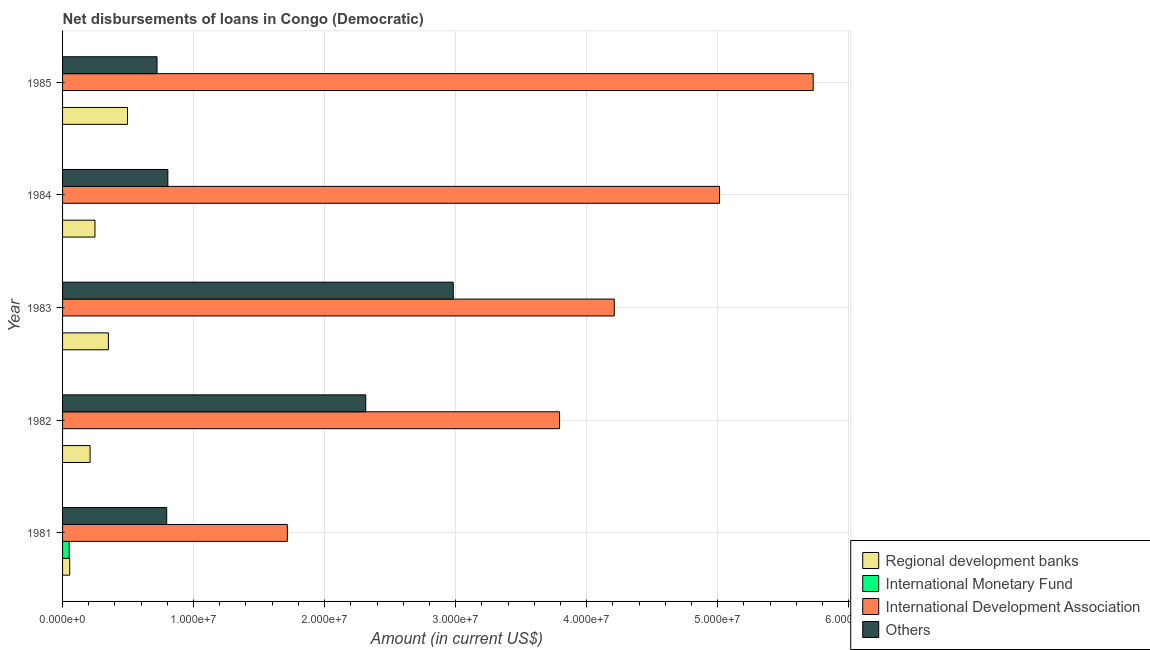How many different coloured bars are there?
Give a very brief answer. 4. Are the number of bars per tick equal to the number of legend labels?
Offer a very short reply. No. How many bars are there on the 4th tick from the top?
Your response must be concise. 3. How many bars are there on the 5th tick from the bottom?
Offer a very short reply. 3. In how many cases, is the number of bars for a given year not equal to the number of legend labels?
Ensure brevity in your answer.  4. What is the amount of loan disimbursed by regional development banks in 1984?
Give a very brief answer. 2.47e+06. Across all years, what is the maximum amount of loan disimbursed by other organisations?
Keep it short and to the point. 2.98e+07. Across all years, what is the minimum amount of loan disimbursed by international development association?
Give a very brief answer. 1.72e+07. What is the total amount of loan disimbursed by international development association in the graph?
Provide a short and direct response. 2.05e+08. What is the difference between the amount of loan disimbursed by international development association in 1981 and that in 1985?
Keep it short and to the point. -4.01e+07. What is the difference between the amount of loan disimbursed by regional development banks in 1981 and the amount of loan disimbursed by international development association in 1982?
Your answer should be very brief. -3.74e+07. What is the average amount of loan disimbursed by international monetary fund per year?
Your response must be concise. 1.01e+05. In the year 1985, what is the difference between the amount of loan disimbursed by international development association and amount of loan disimbursed by regional development banks?
Your response must be concise. 5.23e+07. What is the ratio of the amount of loan disimbursed by regional development banks in 1981 to that in 1985?
Offer a very short reply. 0.11. Is the amount of loan disimbursed by regional development banks in 1984 less than that in 1985?
Ensure brevity in your answer.  Yes. What is the difference between the highest and the second highest amount of loan disimbursed by regional development banks?
Your response must be concise. 1.46e+06. What is the difference between the highest and the lowest amount of loan disimbursed by other organisations?
Your answer should be compact. 2.26e+07. Is the sum of the amount of loan disimbursed by other organisations in 1982 and 1983 greater than the maximum amount of loan disimbursed by international development association across all years?
Your response must be concise. No. Is it the case that in every year, the sum of the amount of loan disimbursed by regional development banks and amount of loan disimbursed by international monetary fund is greater than the amount of loan disimbursed by international development association?
Give a very brief answer. No. How many bars are there?
Your answer should be compact. 16. Are all the bars in the graph horizontal?
Provide a short and direct response. Yes. How many years are there in the graph?
Offer a very short reply. 5. Does the graph contain grids?
Give a very brief answer. Yes. Where does the legend appear in the graph?
Offer a very short reply. Bottom right. How many legend labels are there?
Your answer should be very brief. 4. What is the title of the graph?
Offer a terse response. Net disbursements of loans in Congo (Democratic). Does "Primary education" appear as one of the legend labels in the graph?
Make the answer very short. No. What is the label or title of the Y-axis?
Your response must be concise. Year. What is the Amount (in current US$) of Regional development banks in 1981?
Offer a terse response. 5.46e+05. What is the Amount (in current US$) in International Monetary Fund in 1981?
Give a very brief answer. 5.04e+05. What is the Amount (in current US$) of International Development Association in 1981?
Give a very brief answer. 1.72e+07. What is the Amount (in current US$) of Others in 1981?
Make the answer very short. 7.95e+06. What is the Amount (in current US$) in Regional development banks in 1982?
Make the answer very short. 2.10e+06. What is the Amount (in current US$) of International Monetary Fund in 1982?
Keep it short and to the point. 0. What is the Amount (in current US$) in International Development Association in 1982?
Make the answer very short. 3.79e+07. What is the Amount (in current US$) in Others in 1982?
Offer a very short reply. 2.31e+07. What is the Amount (in current US$) of Regional development banks in 1983?
Keep it short and to the point. 3.50e+06. What is the Amount (in current US$) of International Monetary Fund in 1983?
Offer a very short reply. 0. What is the Amount (in current US$) of International Development Association in 1983?
Ensure brevity in your answer.  4.21e+07. What is the Amount (in current US$) in Others in 1983?
Give a very brief answer. 2.98e+07. What is the Amount (in current US$) in Regional development banks in 1984?
Your response must be concise. 2.47e+06. What is the Amount (in current US$) in International Monetary Fund in 1984?
Provide a short and direct response. 0. What is the Amount (in current US$) in International Development Association in 1984?
Provide a short and direct response. 5.01e+07. What is the Amount (in current US$) in Others in 1984?
Make the answer very short. 8.04e+06. What is the Amount (in current US$) of Regional development banks in 1985?
Make the answer very short. 4.96e+06. What is the Amount (in current US$) in International Monetary Fund in 1985?
Offer a terse response. 0. What is the Amount (in current US$) in International Development Association in 1985?
Provide a short and direct response. 5.73e+07. What is the Amount (in current US$) of Others in 1985?
Offer a terse response. 7.21e+06. Across all years, what is the maximum Amount (in current US$) in Regional development banks?
Provide a succinct answer. 4.96e+06. Across all years, what is the maximum Amount (in current US$) in International Monetary Fund?
Provide a succinct answer. 5.04e+05. Across all years, what is the maximum Amount (in current US$) of International Development Association?
Keep it short and to the point. 5.73e+07. Across all years, what is the maximum Amount (in current US$) of Others?
Keep it short and to the point. 2.98e+07. Across all years, what is the minimum Amount (in current US$) of Regional development banks?
Your answer should be compact. 5.46e+05. Across all years, what is the minimum Amount (in current US$) of International Development Association?
Ensure brevity in your answer.  1.72e+07. Across all years, what is the minimum Amount (in current US$) of Others?
Your answer should be compact. 7.21e+06. What is the total Amount (in current US$) in Regional development banks in the graph?
Keep it short and to the point. 1.36e+07. What is the total Amount (in current US$) in International Monetary Fund in the graph?
Your answer should be compact. 5.04e+05. What is the total Amount (in current US$) of International Development Association in the graph?
Your answer should be compact. 2.05e+08. What is the total Amount (in current US$) of Others in the graph?
Offer a terse response. 7.62e+07. What is the difference between the Amount (in current US$) of Regional development banks in 1981 and that in 1982?
Your answer should be compact. -1.56e+06. What is the difference between the Amount (in current US$) in International Development Association in 1981 and that in 1982?
Ensure brevity in your answer.  -2.08e+07. What is the difference between the Amount (in current US$) in Others in 1981 and that in 1982?
Your answer should be very brief. -1.52e+07. What is the difference between the Amount (in current US$) of Regional development banks in 1981 and that in 1983?
Ensure brevity in your answer.  -2.95e+06. What is the difference between the Amount (in current US$) in International Development Association in 1981 and that in 1983?
Ensure brevity in your answer.  -2.50e+07. What is the difference between the Amount (in current US$) of Others in 1981 and that in 1983?
Give a very brief answer. -2.19e+07. What is the difference between the Amount (in current US$) in Regional development banks in 1981 and that in 1984?
Make the answer very short. -1.93e+06. What is the difference between the Amount (in current US$) in International Development Association in 1981 and that in 1984?
Offer a very short reply. -3.30e+07. What is the difference between the Amount (in current US$) in Others in 1981 and that in 1984?
Your response must be concise. -8.80e+04. What is the difference between the Amount (in current US$) of Regional development banks in 1981 and that in 1985?
Offer a terse response. -4.41e+06. What is the difference between the Amount (in current US$) in International Development Association in 1981 and that in 1985?
Your answer should be very brief. -4.01e+07. What is the difference between the Amount (in current US$) of Others in 1981 and that in 1985?
Offer a terse response. 7.38e+05. What is the difference between the Amount (in current US$) of Regional development banks in 1982 and that in 1983?
Make the answer very short. -1.40e+06. What is the difference between the Amount (in current US$) of International Development Association in 1982 and that in 1983?
Make the answer very short. -4.18e+06. What is the difference between the Amount (in current US$) in Others in 1982 and that in 1983?
Your response must be concise. -6.68e+06. What is the difference between the Amount (in current US$) in Regional development banks in 1982 and that in 1984?
Provide a short and direct response. -3.72e+05. What is the difference between the Amount (in current US$) of International Development Association in 1982 and that in 1984?
Offer a very short reply. -1.22e+07. What is the difference between the Amount (in current US$) of Others in 1982 and that in 1984?
Your answer should be very brief. 1.51e+07. What is the difference between the Amount (in current US$) in Regional development banks in 1982 and that in 1985?
Provide a short and direct response. -2.86e+06. What is the difference between the Amount (in current US$) in International Development Association in 1982 and that in 1985?
Offer a terse response. -1.94e+07. What is the difference between the Amount (in current US$) of Others in 1982 and that in 1985?
Ensure brevity in your answer.  1.59e+07. What is the difference between the Amount (in current US$) of Regional development banks in 1983 and that in 1984?
Make the answer very short. 1.03e+06. What is the difference between the Amount (in current US$) in International Development Association in 1983 and that in 1984?
Provide a short and direct response. -8.03e+06. What is the difference between the Amount (in current US$) of Others in 1983 and that in 1984?
Offer a terse response. 2.18e+07. What is the difference between the Amount (in current US$) in Regional development banks in 1983 and that in 1985?
Make the answer very short. -1.46e+06. What is the difference between the Amount (in current US$) in International Development Association in 1983 and that in 1985?
Offer a terse response. -1.52e+07. What is the difference between the Amount (in current US$) in Others in 1983 and that in 1985?
Ensure brevity in your answer.  2.26e+07. What is the difference between the Amount (in current US$) of Regional development banks in 1984 and that in 1985?
Your answer should be very brief. -2.48e+06. What is the difference between the Amount (in current US$) in International Development Association in 1984 and that in 1985?
Give a very brief answer. -7.15e+06. What is the difference between the Amount (in current US$) of Others in 1984 and that in 1985?
Provide a short and direct response. 8.26e+05. What is the difference between the Amount (in current US$) in Regional development banks in 1981 and the Amount (in current US$) in International Development Association in 1982?
Keep it short and to the point. -3.74e+07. What is the difference between the Amount (in current US$) of Regional development banks in 1981 and the Amount (in current US$) of Others in 1982?
Your answer should be compact. -2.26e+07. What is the difference between the Amount (in current US$) in International Monetary Fund in 1981 and the Amount (in current US$) in International Development Association in 1982?
Offer a very short reply. -3.74e+07. What is the difference between the Amount (in current US$) in International Monetary Fund in 1981 and the Amount (in current US$) in Others in 1982?
Your response must be concise. -2.26e+07. What is the difference between the Amount (in current US$) of International Development Association in 1981 and the Amount (in current US$) of Others in 1982?
Ensure brevity in your answer.  -5.99e+06. What is the difference between the Amount (in current US$) in Regional development banks in 1981 and the Amount (in current US$) in International Development Association in 1983?
Provide a short and direct response. -4.16e+07. What is the difference between the Amount (in current US$) in Regional development banks in 1981 and the Amount (in current US$) in Others in 1983?
Offer a terse response. -2.93e+07. What is the difference between the Amount (in current US$) of International Monetary Fund in 1981 and the Amount (in current US$) of International Development Association in 1983?
Offer a terse response. -4.16e+07. What is the difference between the Amount (in current US$) in International Monetary Fund in 1981 and the Amount (in current US$) in Others in 1983?
Provide a succinct answer. -2.93e+07. What is the difference between the Amount (in current US$) of International Development Association in 1981 and the Amount (in current US$) of Others in 1983?
Keep it short and to the point. -1.27e+07. What is the difference between the Amount (in current US$) in Regional development banks in 1981 and the Amount (in current US$) in International Development Association in 1984?
Your answer should be compact. -4.96e+07. What is the difference between the Amount (in current US$) of Regional development banks in 1981 and the Amount (in current US$) of Others in 1984?
Make the answer very short. -7.49e+06. What is the difference between the Amount (in current US$) in International Monetary Fund in 1981 and the Amount (in current US$) in International Development Association in 1984?
Give a very brief answer. -4.96e+07. What is the difference between the Amount (in current US$) in International Monetary Fund in 1981 and the Amount (in current US$) in Others in 1984?
Offer a very short reply. -7.53e+06. What is the difference between the Amount (in current US$) in International Development Association in 1981 and the Amount (in current US$) in Others in 1984?
Provide a succinct answer. 9.12e+06. What is the difference between the Amount (in current US$) in Regional development banks in 1981 and the Amount (in current US$) in International Development Association in 1985?
Offer a very short reply. -5.67e+07. What is the difference between the Amount (in current US$) of Regional development banks in 1981 and the Amount (in current US$) of Others in 1985?
Your answer should be compact. -6.66e+06. What is the difference between the Amount (in current US$) in International Monetary Fund in 1981 and the Amount (in current US$) in International Development Association in 1985?
Your response must be concise. -5.68e+07. What is the difference between the Amount (in current US$) in International Monetary Fund in 1981 and the Amount (in current US$) in Others in 1985?
Provide a succinct answer. -6.71e+06. What is the difference between the Amount (in current US$) of International Development Association in 1981 and the Amount (in current US$) of Others in 1985?
Your answer should be very brief. 9.94e+06. What is the difference between the Amount (in current US$) of Regional development banks in 1982 and the Amount (in current US$) of International Development Association in 1983?
Provide a short and direct response. -4.00e+07. What is the difference between the Amount (in current US$) of Regional development banks in 1982 and the Amount (in current US$) of Others in 1983?
Ensure brevity in your answer.  -2.77e+07. What is the difference between the Amount (in current US$) of International Development Association in 1982 and the Amount (in current US$) of Others in 1983?
Give a very brief answer. 8.11e+06. What is the difference between the Amount (in current US$) of Regional development banks in 1982 and the Amount (in current US$) of International Development Association in 1984?
Offer a terse response. -4.80e+07. What is the difference between the Amount (in current US$) of Regional development banks in 1982 and the Amount (in current US$) of Others in 1984?
Ensure brevity in your answer.  -5.94e+06. What is the difference between the Amount (in current US$) in International Development Association in 1982 and the Amount (in current US$) in Others in 1984?
Make the answer very short. 2.99e+07. What is the difference between the Amount (in current US$) in Regional development banks in 1982 and the Amount (in current US$) in International Development Association in 1985?
Give a very brief answer. -5.52e+07. What is the difference between the Amount (in current US$) of Regional development banks in 1982 and the Amount (in current US$) of Others in 1985?
Offer a terse response. -5.11e+06. What is the difference between the Amount (in current US$) of International Development Association in 1982 and the Amount (in current US$) of Others in 1985?
Ensure brevity in your answer.  3.07e+07. What is the difference between the Amount (in current US$) of Regional development banks in 1983 and the Amount (in current US$) of International Development Association in 1984?
Offer a very short reply. -4.66e+07. What is the difference between the Amount (in current US$) in Regional development banks in 1983 and the Amount (in current US$) in Others in 1984?
Offer a very short reply. -4.54e+06. What is the difference between the Amount (in current US$) of International Development Association in 1983 and the Amount (in current US$) of Others in 1984?
Provide a short and direct response. 3.41e+07. What is the difference between the Amount (in current US$) in Regional development banks in 1983 and the Amount (in current US$) in International Development Association in 1985?
Ensure brevity in your answer.  -5.38e+07. What is the difference between the Amount (in current US$) in Regional development banks in 1983 and the Amount (in current US$) in Others in 1985?
Your answer should be compact. -3.71e+06. What is the difference between the Amount (in current US$) in International Development Association in 1983 and the Amount (in current US$) in Others in 1985?
Your answer should be very brief. 3.49e+07. What is the difference between the Amount (in current US$) of Regional development banks in 1984 and the Amount (in current US$) of International Development Association in 1985?
Your answer should be very brief. -5.48e+07. What is the difference between the Amount (in current US$) in Regional development banks in 1984 and the Amount (in current US$) in Others in 1985?
Ensure brevity in your answer.  -4.74e+06. What is the difference between the Amount (in current US$) of International Development Association in 1984 and the Amount (in current US$) of Others in 1985?
Offer a terse response. 4.29e+07. What is the average Amount (in current US$) of Regional development banks per year?
Offer a very short reply. 2.72e+06. What is the average Amount (in current US$) of International Monetary Fund per year?
Provide a short and direct response. 1.01e+05. What is the average Amount (in current US$) in International Development Association per year?
Offer a very short reply. 4.09e+07. What is the average Amount (in current US$) in Others per year?
Ensure brevity in your answer.  1.52e+07. In the year 1981, what is the difference between the Amount (in current US$) of Regional development banks and Amount (in current US$) of International Monetary Fund?
Make the answer very short. 4.20e+04. In the year 1981, what is the difference between the Amount (in current US$) of Regional development banks and Amount (in current US$) of International Development Association?
Ensure brevity in your answer.  -1.66e+07. In the year 1981, what is the difference between the Amount (in current US$) of Regional development banks and Amount (in current US$) of Others?
Give a very brief answer. -7.40e+06. In the year 1981, what is the difference between the Amount (in current US$) of International Monetary Fund and Amount (in current US$) of International Development Association?
Provide a short and direct response. -1.67e+07. In the year 1981, what is the difference between the Amount (in current US$) of International Monetary Fund and Amount (in current US$) of Others?
Your answer should be very brief. -7.44e+06. In the year 1981, what is the difference between the Amount (in current US$) in International Development Association and Amount (in current US$) in Others?
Give a very brief answer. 9.21e+06. In the year 1982, what is the difference between the Amount (in current US$) in Regional development banks and Amount (in current US$) in International Development Association?
Provide a short and direct response. -3.58e+07. In the year 1982, what is the difference between the Amount (in current US$) of Regional development banks and Amount (in current US$) of Others?
Your answer should be compact. -2.10e+07. In the year 1982, what is the difference between the Amount (in current US$) in International Development Association and Amount (in current US$) in Others?
Offer a very short reply. 1.48e+07. In the year 1983, what is the difference between the Amount (in current US$) in Regional development banks and Amount (in current US$) in International Development Association?
Provide a succinct answer. -3.86e+07. In the year 1983, what is the difference between the Amount (in current US$) of Regional development banks and Amount (in current US$) of Others?
Provide a short and direct response. -2.63e+07. In the year 1983, what is the difference between the Amount (in current US$) in International Development Association and Amount (in current US$) in Others?
Offer a terse response. 1.23e+07. In the year 1984, what is the difference between the Amount (in current US$) in Regional development banks and Amount (in current US$) in International Development Association?
Your response must be concise. -4.77e+07. In the year 1984, what is the difference between the Amount (in current US$) in Regional development banks and Amount (in current US$) in Others?
Your answer should be very brief. -5.56e+06. In the year 1984, what is the difference between the Amount (in current US$) of International Development Association and Amount (in current US$) of Others?
Offer a very short reply. 4.21e+07. In the year 1985, what is the difference between the Amount (in current US$) of Regional development banks and Amount (in current US$) of International Development Association?
Give a very brief answer. -5.23e+07. In the year 1985, what is the difference between the Amount (in current US$) of Regional development banks and Amount (in current US$) of Others?
Provide a succinct answer. -2.25e+06. In the year 1985, what is the difference between the Amount (in current US$) of International Development Association and Amount (in current US$) of Others?
Keep it short and to the point. 5.01e+07. What is the ratio of the Amount (in current US$) of Regional development banks in 1981 to that in 1982?
Keep it short and to the point. 0.26. What is the ratio of the Amount (in current US$) of International Development Association in 1981 to that in 1982?
Your response must be concise. 0.45. What is the ratio of the Amount (in current US$) in Others in 1981 to that in 1982?
Provide a succinct answer. 0.34. What is the ratio of the Amount (in current US$) in Regional development banks in 1981 to that in 1983?
Your response must be concise. 0.16. What is the ratio of the Amount (in current US$) of International Development Association in 1981 to that in 1983?
Give a very brief answer. 0.41. What is the ratio of the Amount (in current US$) in Others in 1981 to that in 1983?
Keep it short and to the point. 0.27. What is the ratio of the Amount (in current US$) of Regional development banks in 1981 to that in 1984?
Offer a terse response. 0.22. What is the ratio of the Amount (in current US$) of International Development Association in 1981 to that in 1984?
Give a very brief answer. 0.34. What is the ratio of the Amount (in current US$) in Regional development banks in 1981 to that in 1985?
Your response must be concise. 0.11. What is the ratio of the Amount (in current US$) in International Development Association in 1981 to that in 1985?
Keep it short and to the point. 0.3. What is the ratio of the Amount (in current US$) of Others in 1981 to that in 1985?
Your answer should be very brief. 1.1. What is the ratio of the Amount (in current US$) of Regional development banks in 1982 to that in 1983?
Ensure brevity in your answer.  0.6. What is the ratio of the Amount (in current US$) of International Development Association in 1982 to that in 1983?
Your answer should be compact. 0.9. What is the ratio of the Amount (in current US$) in Others in 1982 to that in 1983?
Provide a succinct answer. 0.78. What is the ratio of the Amount (in current US$) of Regional development banks in 1982 to that in 1984?
Keep it short and to the point. 0.85. What is the ratio of the Amount (in current US$) in International Development Association in 1982 to that in 1984?
Provide a short and direct response. 0.76. What is the ratio of the Amount (in current US$) in Others in 1982 to that in 1984?
Keep it short and to the point. 2.88. What is the ratio of the Amount (in current US$) in Regional development banks in 1982 to that in 1985?
Provide a short and direct response. 0.42. What is the ratio of the Amount (in current US$) of International Development Association in 1982 to that in 1985?
Give a very brief answer. 0.66. What is the ratio of the Amount (in current US$) of Others in 1982 to that in 1985?
Make the answer very short. 3.21. What is the ratio of the Amount (in current US$) in Regional development banks in 1983 to that in 1984?
Ensure brevity in your answer.  1.41. What is the ratio of the Amount (in current US$) in International Development Association in 1983 to that in 1984?
Provide a short and direct response. 0.84. What is the ratio of the Amount (in current US$) of Others in 1983 to that in 1984?
Provide a short and direct response. 3.71. What is the ratio of the Amount (in current US$) in Regional development banks in 1983 to that in 1985?
Your response must be concise. 0.71. What is the ratio of the Amount (in current US$) of International Development Association in 1983 to that in 1985?
Make the answer very short. 0.73. What is the ratio of the Amount (in current US$) in Others in 1983 to that in 1985?
Offer a very short reply. 4.14. What is the ratio of the Amount (in current US$) in Regional development banks in 1984 to that in 1985?
Provide a short and direct response. 0.5. What is the ratio of the Amount (in current US$) of International Development Association in 1984 to that in 1985?
Give a very brief answer. 0.88. What is the ratio of the Amount (in current US$) in Others in 1984 to that in 1985?
Offer a very short reply. 1.11. What is the difference between the highest and the second highest Amount (in current US$) in Regional development banks?
Provide a short and direct response. 1.46e+06. What is the difference between the highest and the second highest Amount (in current US$) in International Development Association?
Ensure brevity in your answer.  7.15e+06. What is the difference between the highest and the second highest Amount (in current US$) of Others?
Provide a succinct answer. 6.68e+06. What is the difference between the highest and the lowest Amount (in current US$) of Regional development banks?
Make the answer very short. 4.41e+06. What is the difference between the highest and the lowest Amount (in current US$) of International Monetary Fund?
Your answer should be compact. 5.04e+05. What is the difference between the highest and the lowest Amount (in current US$) of International Development Association?
Provide a short and direct response. 4.01e+07. What is the difference between the highest and the lowest Amount (in current US$) of Others?
Your answer should be compact. 2.26e+07. 